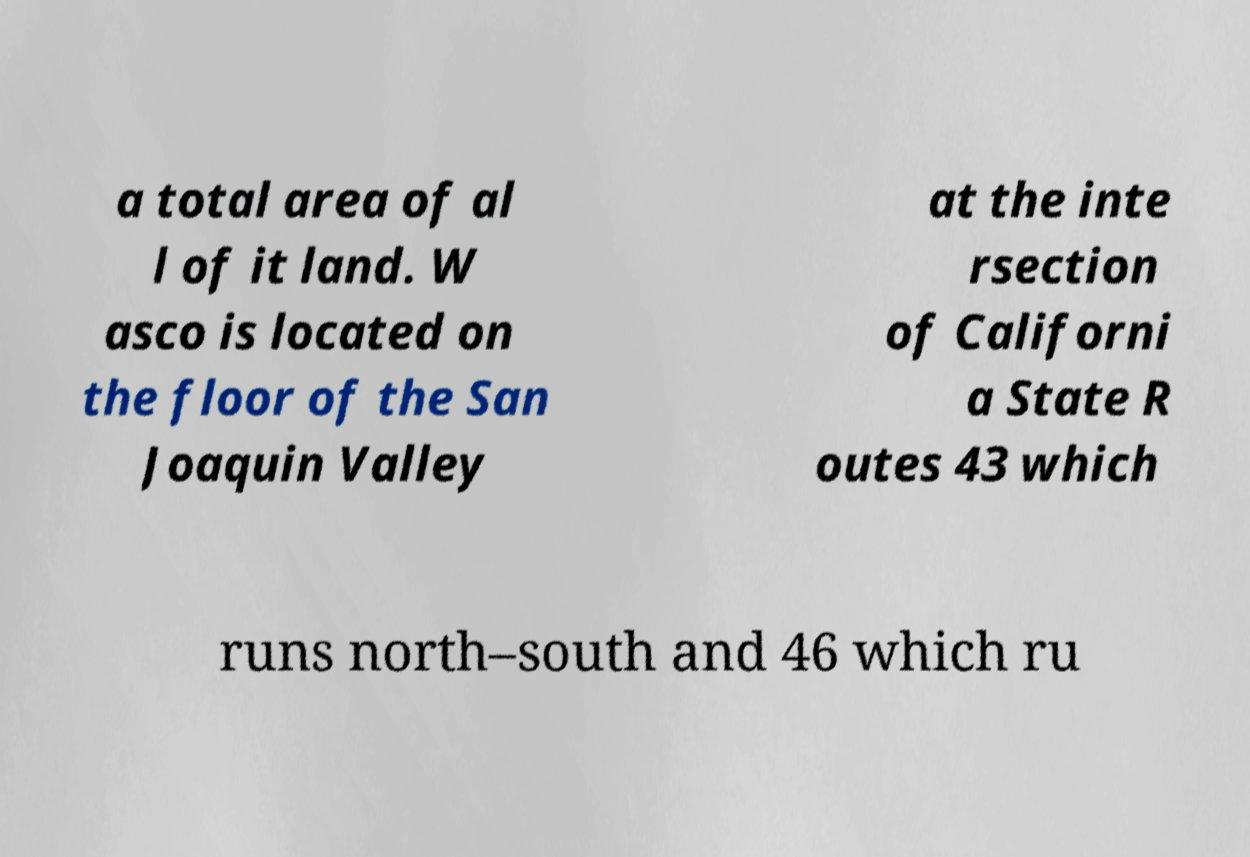Could you assist in decoding the text presented in this image and type it out clearly? a total area of al l of it land. W asco is located on the floor of the San Joaquin Valley at the inte rsection of Californi a State R outes 43 which runs north–south and 46 which ru 